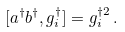Convert formula to latex. <formula><loc_0><loc_0><loc_500><loc_500>[ a ^ { \dagger } b ^ { \dagger } , { \sl g } ^ { \dagger } _ { i } ] = { \sl g } ^ { \dagger 2 } _ { i } \, .</formula> 